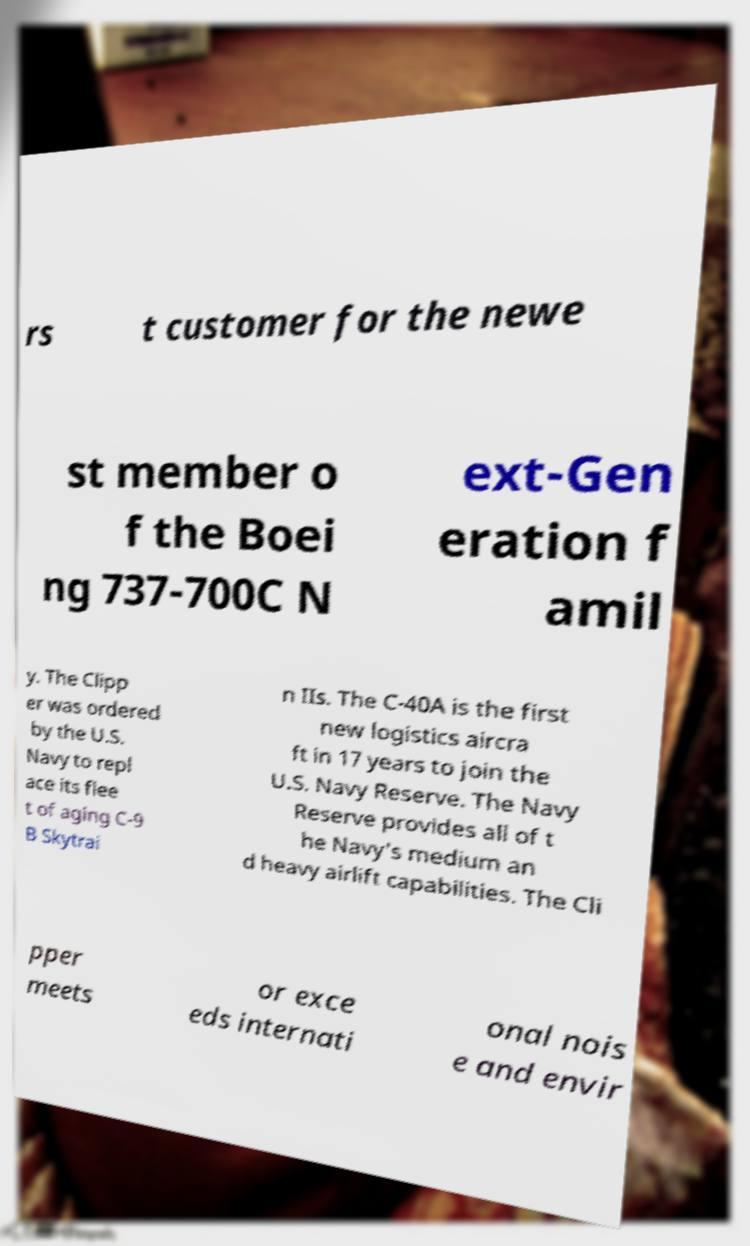Please read and relay the text visible in this image. What does it say? rs t customer for the newe st member o f the Boei ng 737-700C N ext-Gen eration f amil y. The Clipp er was ordered by the U.S. Navy to repl ace its flee t of aging C-9 B Skytrai n IIs. The C-40A is the first new logistics aircra ft in 17 years to join the U.S. Navy Reserve. The Navy Reserve provides all of t he Navy's medium an d heavy airlift capabilities. The Cli pper meets or exce eds internati onal nois e and envir 